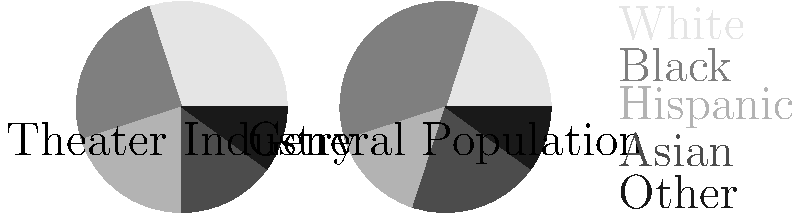As a theater club leader advocating for social justice, you're analyzing demographic representation in the theater industry compared to the general population. The pie charts show the demographic breakdown for both groups. What is the difference between the percentage of Black representation in the theater industry and the general population? To solve this problem, we need to follow these steps:

1. Identify the percentage of Black representation in the theater industry:
   From the "Theater Industry" pie chart, we can see that Black representation is 25%.

2. Identify the percentage of Black representation in the general population:
   From the "General Population" pie chart, we can see that Black representation is 35%.

3. Calculate the difference between these two percentages:
   $35\% - 25\% = 10\%$

This 10% difference indicates an underrepresentation of Black individuals in the theater industry compared to their presence in the general population. This type of analysis is crucial for identifying disparities and promoting diversity and inclusion in various sectors, which aligns with the goals of a social justice-focused theater club.
Answer: 10% 